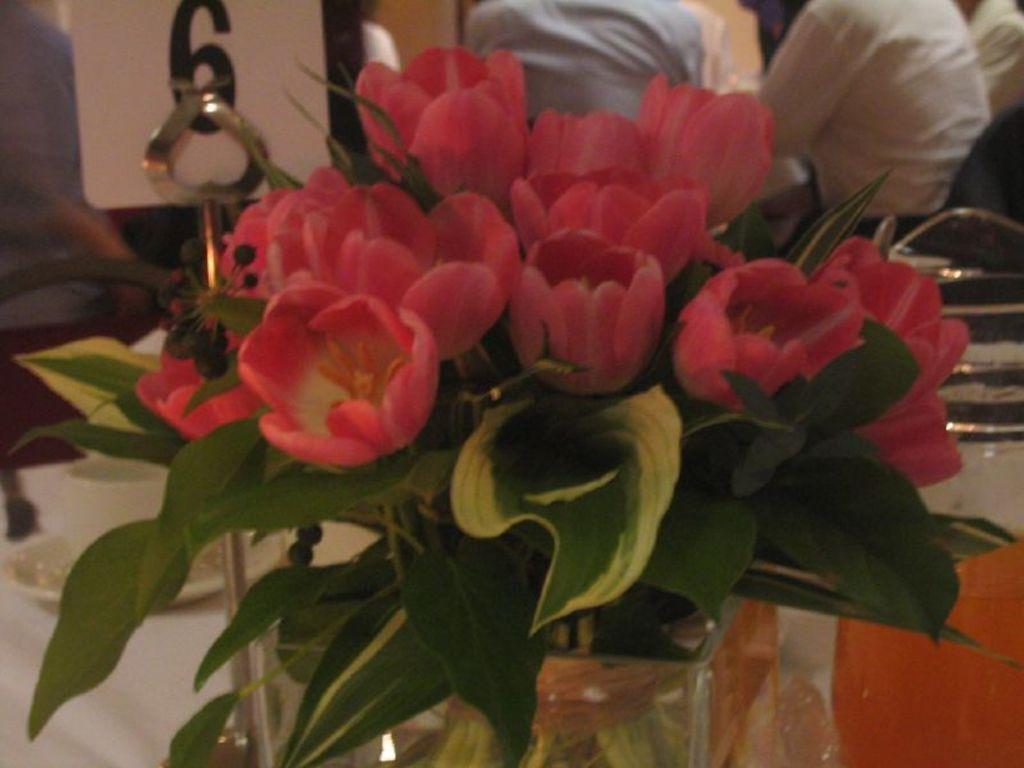Describe this image in one or two sentences. In this image, we can see flowers and leaves. At the bottom, we can see few objects, cloth and rod stand. Background we can see few people, board and some items. 